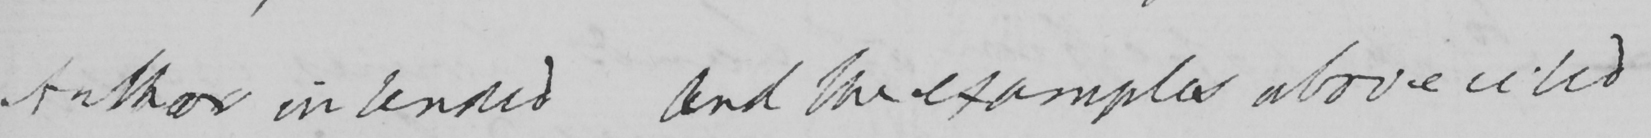Can you read and transcribe this handwriting? Author intended and the examples above cited 